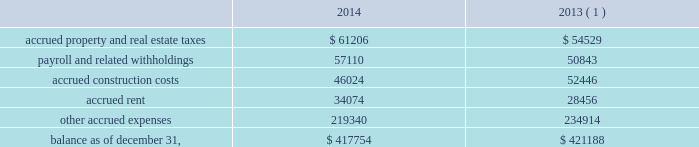American tower corporation and subsidiaries notes to consolidated financial statements acquisition accounting upon closing of the acquisition .
Based on current estimates , the company expects the value of potential contingent consideration payments required to be made under these agreements to be between zero and $ 4.4 million .
During the year ended december 31 , 2014 , the company ( i ) recorded a decrease in fair value of $ 1.7 million in other operating expenses in the accompanying consolidated statements of operations , ( ii ) recorded settlements under these agreements of $ 3.5 million , ( iii ) reduced its contingent consideration liability by $ 0.7 million as a portion of the company 2019s obligations was assumed by the buyer in conjunction with the sale of operations in panama and ( iv ) recorded additional liability of $ 0.1 million .
As a result , the company estimates the value of potential contingent consideration payments required under these agreements to be $ 2.3 million using a probability weighted average of the expected outcomes as of december 31 , 2014 .
Other u.s . 2014in connection with other acquisitions in the united states , the company is required to make additional payments if certain pre-designated tenant leases commence during a specified period of time .
During the year ended december 31 , 2014 , the company recorded $ 6.3 million of contingent consideration liability as part of the preliminary acquisition accounting upon closing of certain acquisitions .
During the year ended december 31 , 2014 , the company recorded settlements under these agreements of $ 0.4 million .
Based on current estimates , the company expects the value of potential contingent consideration payments required to be made under these agreements to be between zero and $ 5.9 million and estimates it to be $ 5.9 million using a probability weighted average of the expected outcomes as of december 31 , 2014 .
For more information regarding contingent consideration , see note 12 .
Accrued expenses accrued expenses consists of the following as of december 31 , ( in thousands ) : .
( 1 ) december 31 , 2013 balances have been revised to reflect purchase accounting measurement period adjustments. .
How much of the of contingent consideration for acquisitions was actually settled in 2014? 
Computations: (0.4 / 6.3)
Answer: 0.06349. 